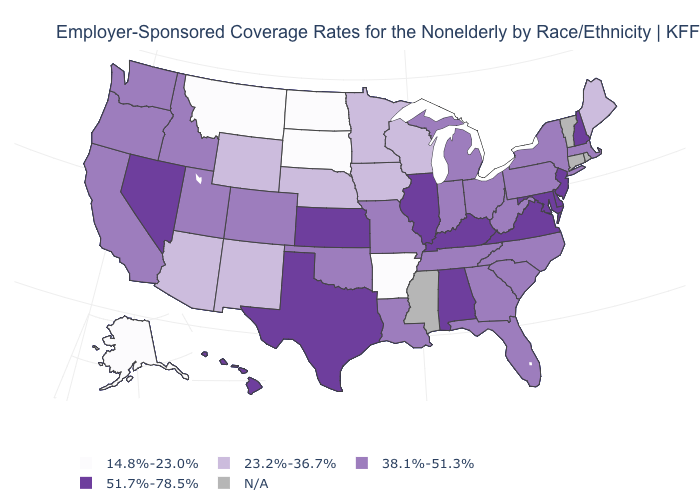What is the highest value in the USA?
Quick response, please. 51.7%-78.5%. How many symbols are there in the legend?
Be succinct. 5. What is the value of Virginia?
Answer briefly. 51.7%-78.5%. What is the lowest value in states that border Texas?
Give a very brief answer. 14.8%-23.0%. Name the states that have a value in the range 14.8%-23.0%?
Short answer required. Alaska, Arkansas, Montana, North Dakota, South Dakota. What is the highest value in states that border New Mexico?
Keep it brief. 51.7%-78.5%. What is the value of Illinois?
Quick response, please. 51.7%-78.5%. Is the legend a continuous bar?
Write a very short answer. No. What is the lowest value in the USA?
Keep it brief. 14.8%-23.0%. Which states have the highest value in the USA?
Write a very short answer. Alabama, Delaware, Hawaii, Illinois, Kansas, Kentucky, Maryland, Nevada, New Hampshire, New Jersey, Texas, Virginia. Does Arizona have the highest value in the USA?
Concise answer only. No. What is the value of Oklahoma?
Be succinct. 38.1%-51.3%. Name the states that have a value in the range N/A?
Concise answer only. Connecticut, Mississippi, Rhode Island, Vermont. Name the states that have a value in the range 23.2%-36.7%?
Be succinct. Arizona, Iowa, Maine, Minnesota, Nebraska, New Mexico, Wisconsin, Wyoming. What is the lowest value in the USA?
Short answer required. 14.8%-23.0%. 